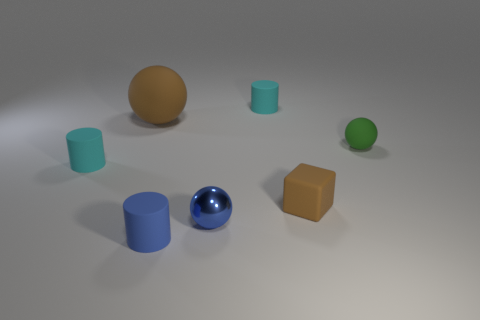Add 2 tiny green rubber balls. How many objects exist? 9 Subtract all cylinders. How many objects are left? 4 Subtract 0 cyan blocks. How many objects are left? 7 Subtract all rubber balls. Subtract all large objects. How many objects are left? 4 Add 3 brown matte objects. How many brown matte objects are left? 5 Add 6 green spheres. How many green spheres exist? 7 